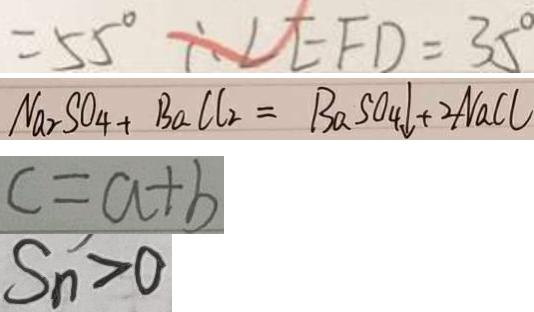Convert formula to latex. <formula><loc_0><loc_0><loc_500><loc_500>= 5 5 ^ { \circ } \therefore \angle E F D = 3 5 ^ { \circ } 
 N a _ { 2 } S O _ { 4 } + B a C l _ { 2 } = B a S O _ { 4 } \downarrow + 2 N a C l 
 c = a + b 
 S _ { n } > 0</formula> 